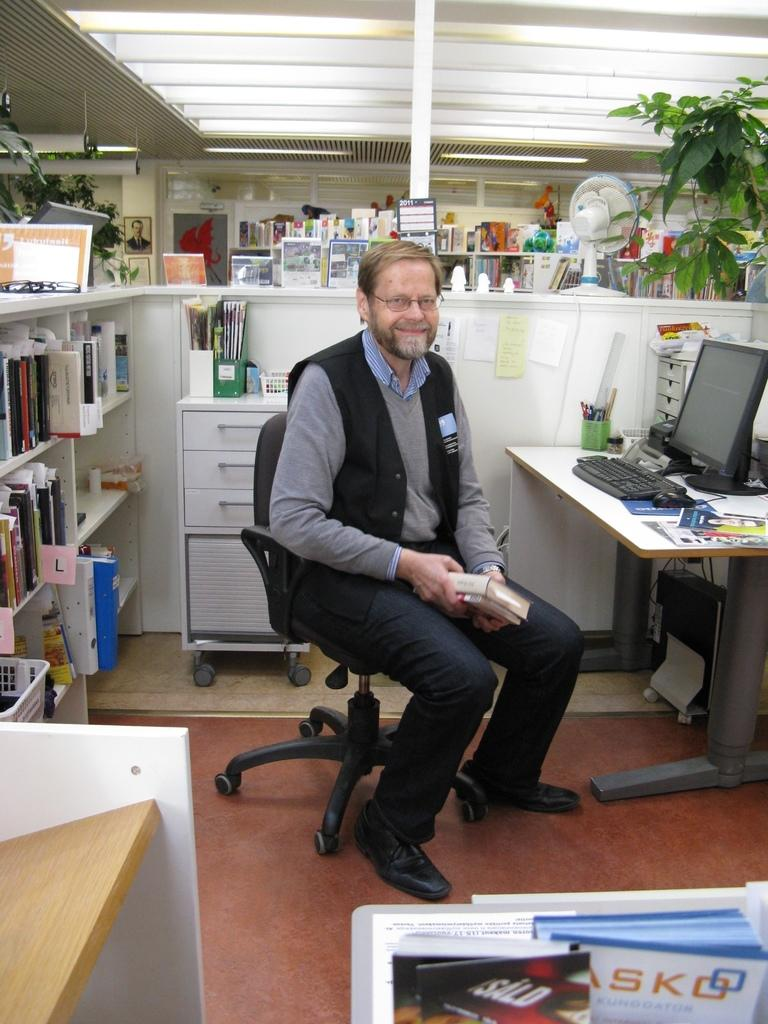<image>
Write a terse but informative summary of the picture. A man sits in his office chair in front of a book shelf that contains an "L" tab. 